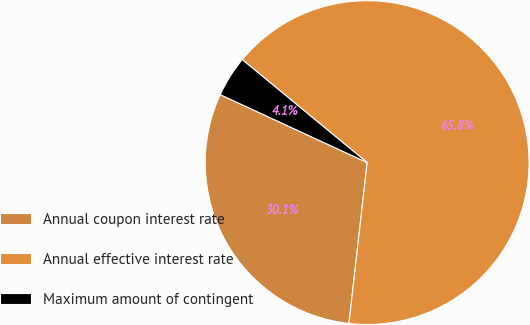Convert chart to OTSL. <chart><loc_0><loc_0><loc_500><loc_500><pie_chart><fcel>Annual coupon interest rate<fcel>Annual effective interest rate<fcel>Maximum amount of contingent<nl><fcel>30.1%<fcel>65.82%<fcel>4.08%<nl></chart> 